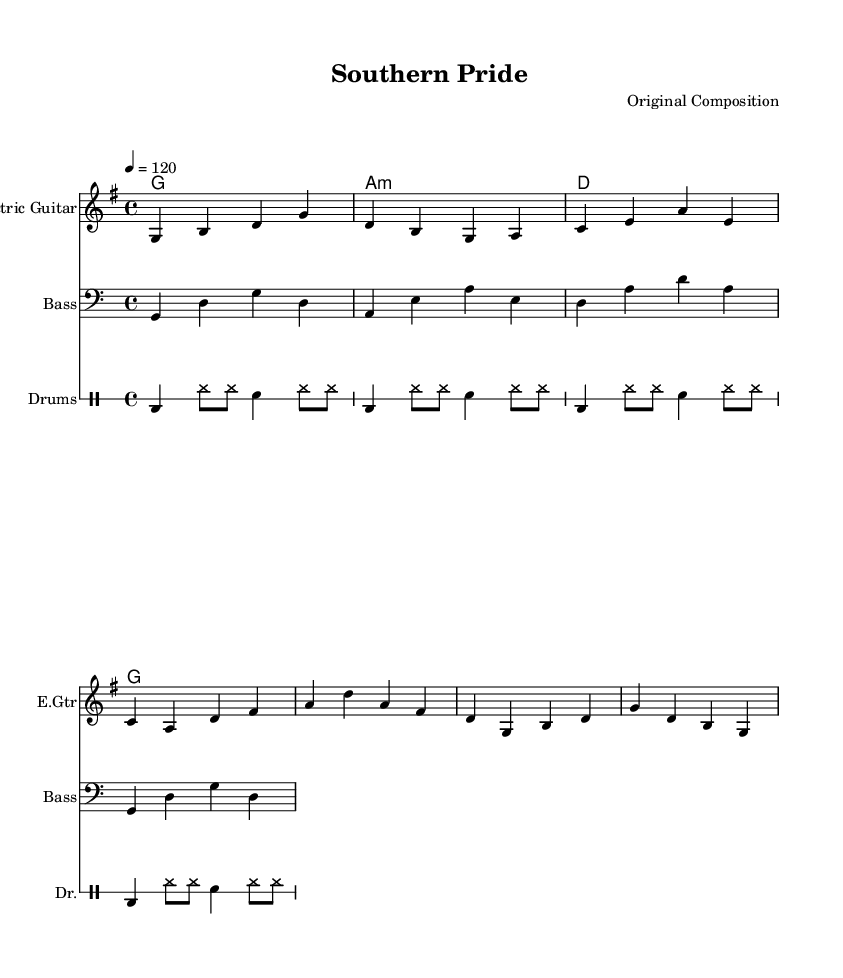What is the key signature of this music? The key signature displayed at the beginning of the score indicates G major, which has one sharp. This can be confirmed by looking for the sharp symbol at the F line on the staff.
Answer: G major What is the time signature of this music? The time signature is indicated at the beginning of the score with the numbers "4/4" placed on the staff, meaning there are four beats per measure and the quarter note gets one beat.
Answer: 4/4 What is the tempo marking for this piece? The tempo is indicated in the score by the words "4 = 120", meaning each quarter note should be played at 120 beats per minute. This helps to set the speed for the performance.
Answer: 120 How many measures are in the melody line? To count the measures in the melody, we look for the vertical lines (bar lines) that separate the sections. There are four measures present in the melody as inferred from the grouping of notes before each bar line.
Answer: 4 What is the style of drum pattern used in this music? The drum section uses a standard rock pattern characterized by bass drum and snare hits, which can be identified by looking at the regular occurrence of bass and snare notes. This pattern is common in Southern rock anthems.
Answer: Rock pattern What chord follows the A minor in the harmony section? By looking at the chord progression, we see that the chord changes after A minor is D major. This is determined by the sequence of chords outlined in the harmonies section of the sheet music.
Answer: D major What instrument is primarily featured in the melody? The melody is primarily notated for the "Electric Guitar," as stated in the staff label at the beginning of the melody line. This indicates the instrument intended to play the main melody.
Answer: Electric Guitar 